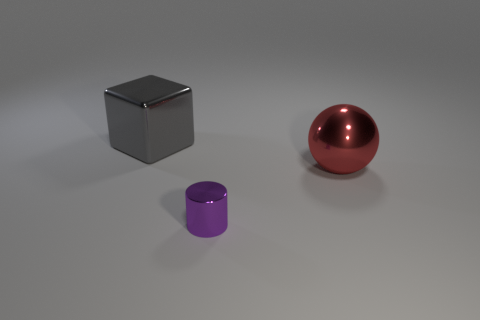Are there any other things that are the same size as the purple metal thing?
Offer a terse response. No. How many purple objects are either shiny balls or metal cylinders?
Keep it short and to the point. 1. What number of gray objects are the same size as the red ball?
Your answer should be very brief. 1. What number of objects are tiny red matte spheres or shiny things that are behind the small purple thing?
Your response must be concise. 2. There is a thing that is to the left of the cylinder; is its size the same as the thing that is on the right side of the purple cylinder?
Provide a short and direct response. Yes. There is a small purple object that is made of the same material as the ball; what is its shape?
Keep it short and to the point. Cylinder. There is a large thing in front of the gray metal object that is behind the big thing that is on the right side of the purple object; what is its material?
Give a very brief answer. Metal. There is a sphere; is its size the same as the shiny object in front of the red thing?
Offer a terse response. No. How big is the object that is behind the large metal object in front of the object that is behind the big ball?
Offer a very short reply. Large. Do the cube and the red metal object have the same size?
Offer a very short reply. Yes. 